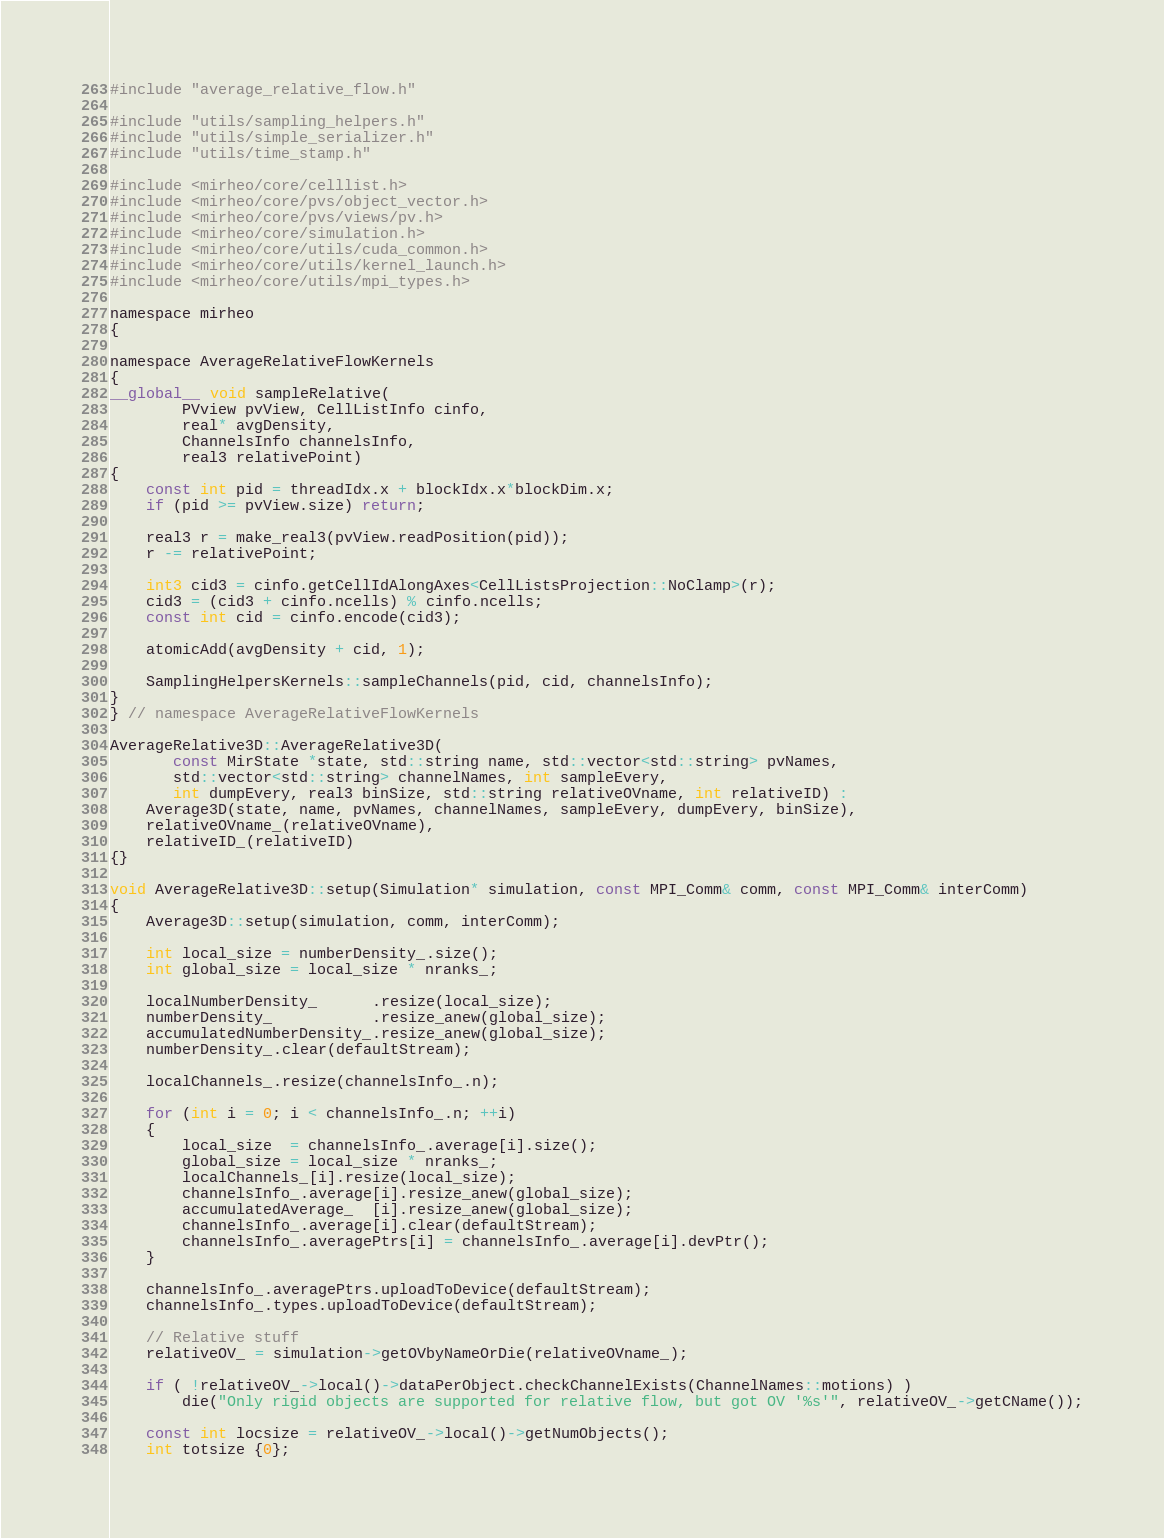Convert code to text. <code><loc_0><loc_0><loc_500><loc_500><_Cuda_>#include "average_relative_flow.h"

#include "utils/sampling_helpers.h"
#include "utils/simple_serializer.h"
#include "utils/time_stamp.h"

#include <mirheo/core/celllist.h>
#include <mirheo/core/pvs/object_vector.h>
#include <mirheo/core/pvs/views/pv.h>
#include <mirheo/core/simulation.h>
#include <mirheo/core/utils/cuda_common.h>
#include <mirheo/core/utils/kernel_launch.h>
#include <mirheo/core/utils/mpi_types.h>

namespace mirheo
{

namespace AverageRelativeFlowKernels
{
__global__ void sampleRelative(
        PVview pvView, CellListInfo cinfo,
        real* avgDensity,
        ChannelsInfo channelsInfo,
        real3 relativePoint)
{
    const int pid = threadIdx.x + blockIdx.x*blockDim.x;
    if (pid >= pvView.size) return;

    real3 r = make_real3(pvView.readPosition(pid));
    r -= relativePoint;

    int3 cid3 = cinfo.getCellIdAlongAxes<CellListsProjection::NoClamp>(r);
    cid3 = (cid3 + cinfo.ncells) % cinfo.ncells;
    const int cid = cinfo.encode(cid3);

    atomicAdd(avgDensity + cid, 1);

    SamplingHelpersKernels::sampleChannels(pid, cid, channelsInfo);
}
} // namespace AverageRelativeFlowKernels

AverageRelative3D::AverageRelative3D(
       const MirState *state, std::string name, std::vector<std::string> pvNames,
       std::vector<std::string> channelNames, int sampleEvery,
       int dumpEvery, real3 binSize, std::string relativeOVname, int relativeID) :
    Average3D(state, name, pvNames, channelNames, sampleEvery, dumpEvery, binSize),
    relativeOVname_(relativeOVname),
    relativeID_(relativeID)
{}

void AverageRelative3D::setup(Simulation* simulation, const MPI_Comm& comm, const MPI_Comm& interComm)
{
    Average3D::setup(simulation, comm, interComm);

    int local_size = numberDensity_.size();
    int global_size = local_size * nranks_;
    
    localNumberDensity_      .resize(local_size);
    numberDensity_           .resize_anew(global_size);
    accumulatedNumberDensity_.resize_anew(global_size);
    numberDensity_.clear(defaultStream);

    localChannels_.resize(channelsInfo_.n);

    for (int i = 0; i < channelsInfo_.n; ++i)
    {
        local_size  = channelsInfo_.average[i].size();
        global_size = local_size * nranks_;
        localChannels_[i].resize(local_size);
        channelsInfo_.average[i].resize_anew(global_size);
        accumulatedAverage_  [i].resize_anew(global_size);
        channelsInfo_.average[i].clear(defaultStream);
        channelsInfo_.averagePtrs[i] = channelsInfo_.average[i].devPtr();
    }

    channelsInfo_.averagePtrs.uploadToDevice(defaultStream);
    channelsInfo_.types.uploadToDevice(defaultStream);

    // Relative stuff
    relativeOV_ = simulation->getOVbyNameOrDie(relativeOVname_);

    if ( !relativeOV_->local()->dataPerObject.checkChannelExists(ChannelNames::motions) )
        die("Only rigid objects are supported for relative flow, but got OV '%s'", relativeOV_->getCName());

    const int locsize = relativeOV_->local()->getNumObjects();
    int totsize {0};
</code> 